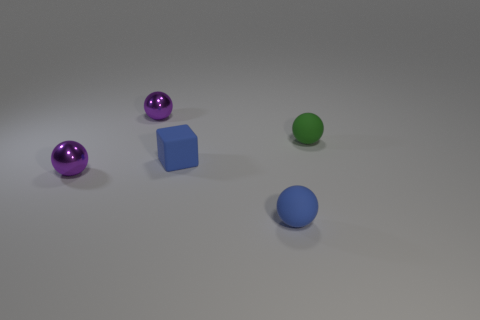How many objects are there total, and can you describe their shapes? In total, there are four objects within this image. Starting from the left, there's a purple sphere with a reflective surface, followed by another similar purple sphere. Next, there is a solid blue cube with a matte finish, and on the far right, there's a smaller, matte green sphere. 